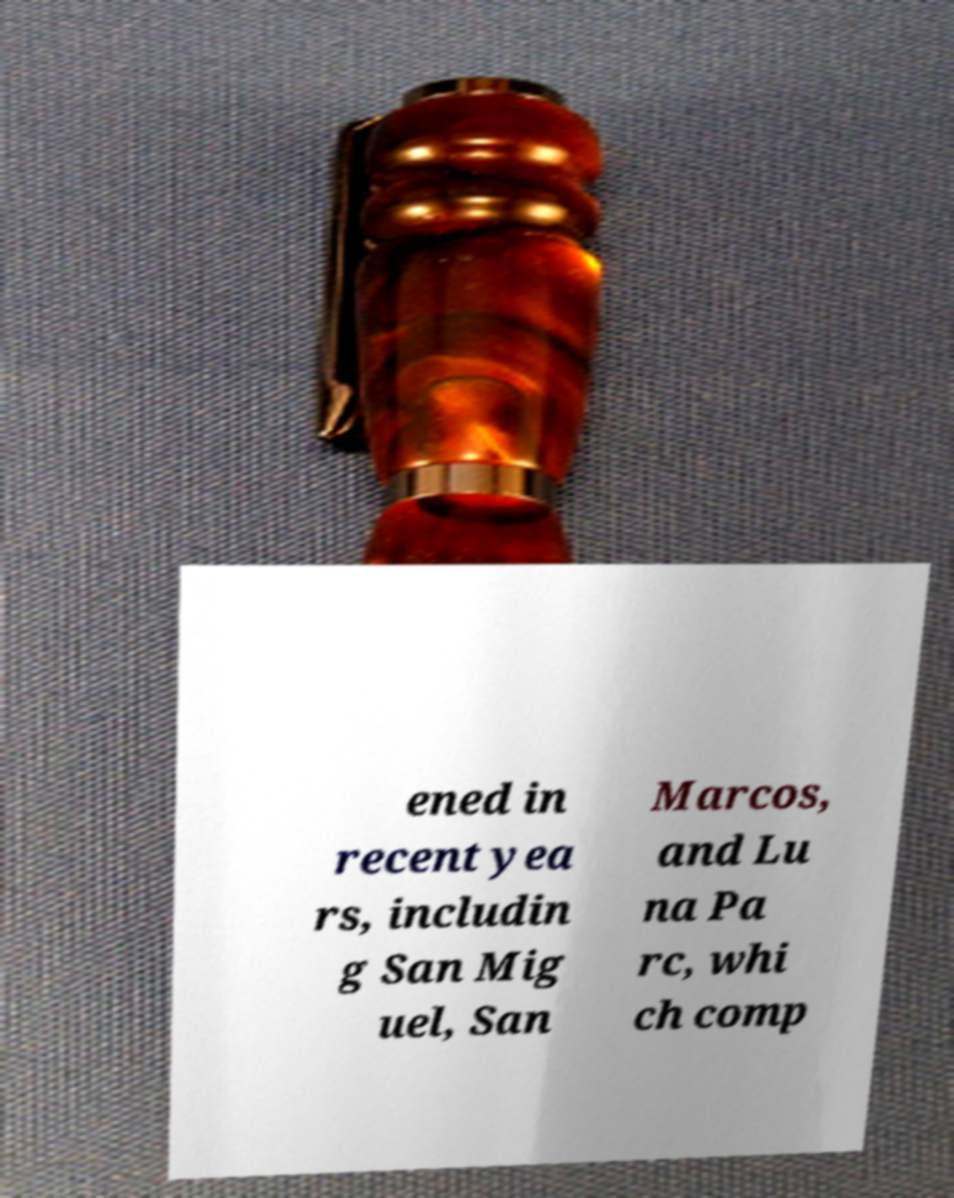There's text embedded in this image that I need extracted. Can you transcribe it verbatim? ened in recent yea rs, includin g San Mig uel, San Marcos, and Lu na Pa rc, whi ch comp 